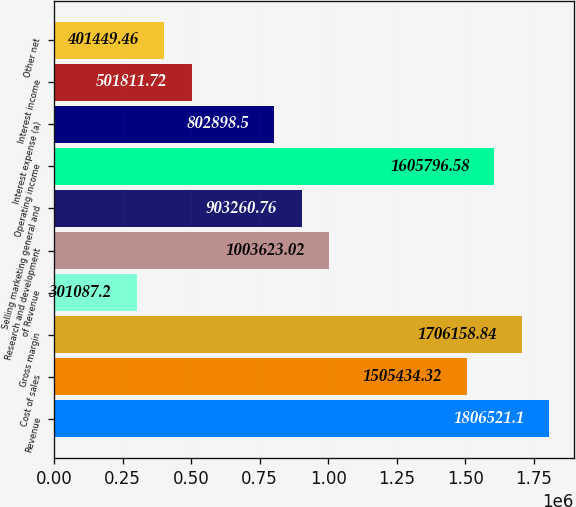Convert chart to OTSL. <chart><loc_0><loc_0><loc_500><loc_500><bar_chart><fcel>Revenue<fcel>Cost of sales<fcel>Gross margin<fcel>of Revenue<fcel>Research and development<fcel>Selling marketing general and<fcel>Operating income<fcel>Interest expense (a)<fcel>Interest income<fcel>Other net<nl><fcel>1.80652e+06<fcel>1.50543e+06<fcel>1.70616e+06<fcel>301087<fcel>1.00362e+06<fcel>903261<fcel>1.6058e+06<fcel>802898<fcel>501812<fcel>401449<nl></chart> 